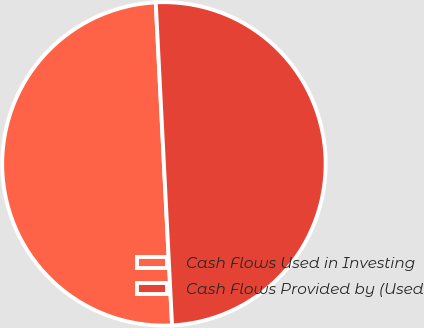<chart> <loc_0><loc_0><loc_500><loc_500><pie_chart><fcel>Cash Flows Used in Investing<fcel>Cash Flows Provided by (Used<nl><fcel>50.0%<fcel>50.0%<nl></chart> 